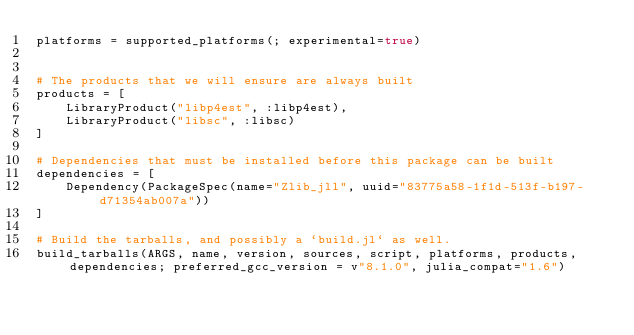Convert code to text. <code><loc_0><loc_0><loc_500><loc_500><_Julia_>platforms = supported_platforms(; experimental=true)


# The products that we will ensure are always built
products = [
    LibraryProduct("libp4est", :libp4est),
    LibraryProduct("libsc", :libsc)
]

# Dependencies that must be installed before this package can be built
dependencies = [
    Dependency(PackageSpec(name="Zlib_jll", uuid="83775a58-1f1d-513f-b197-d71354ab007a"))
]

# Build the tarballs, and possibly a `build.jl` as well.
build_tarballs(ARGS, name, version, sources, script, platforms, products, dependencies; preferred_gcc_version = v"8.1.0", julia_compat="1.6")
</code> 